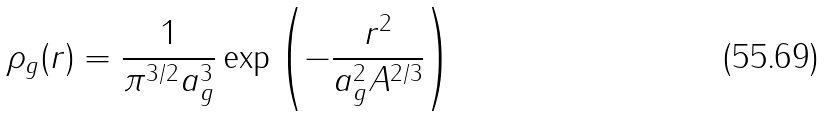<formula> <loc_0><loc_0><loc_500><loc_500>\rho _ { g } ( r ) = \frac { 1 } { \pi ^ { 3 / 2 } a _ { g } ^ { 3 } } \exp \left ( - \frac { r ^ { 2 } } { a _ { g } ^ { 2 } A ^ { 2 / 3 } } \right )</formula> 